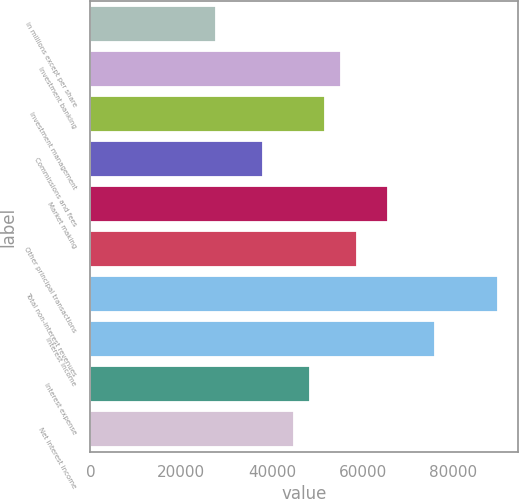Convert chart. <chart><loc_0><loc_0><loc_500><loc_500><bar_chart><fcel>in millions except per share<fcel>Investment banking<fcel>Investment management<fcel>Commissions and fees<fcel>Market making<fcel>Other principal transactions<fcel>Total non-interest revenues<fcel>Interest income<fcel>Interest expense<fcel>Net interest income<nl><fcel>27625.8<fcel>55234.5<fcel>51783.4<fcel>37979.1<fcel>65587.8<fcel>58685.6<fcel>89745.4<fcel>75941.1<fcel>48332.3<fcel>44881.2<nl></chart> 